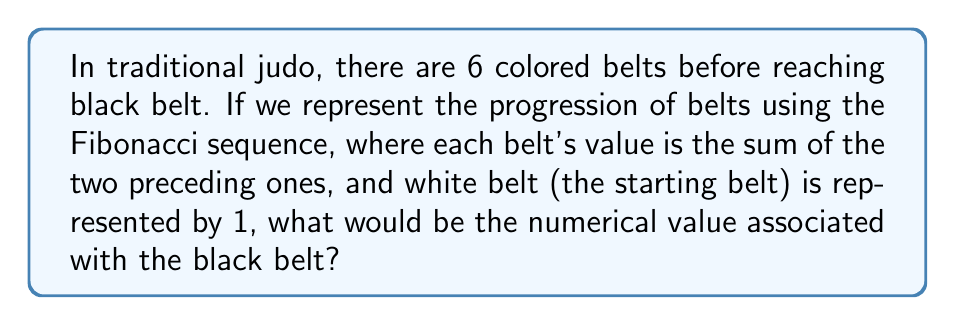Show me your answer to this math problem. Let's approach this step-by-step:

1) The Fibonacci sequence starts with 1, 1, and each subsequent number is the sum of the two preceding ones.

2) The belt progression in judo typically follows this order: White, Yellow, Orange, Green, Blue, Brown, Black.

3) Let's assign the Fibonacci numbers to each belt:

   White: 1
   Yellow: 1
   Orange: $1 + 1 = 2$
   Green: $1 + 2 = 3$
   Blue: $2 + 3 = 5$
   Brown: $3 + 5 = 8$
   Black: $5 + 8 = 13$

4) We can represent this mathematically as:

   $$F_n = F_{n-1} + F_{n-2}$$

   Where $F_n$ is the nth term in the Fibonacci sequence.

5) In this case, the black belt is the 7th term in our sequence (as it's the 7th belt), so we're looking for $F_7$.

6) The sequence for the belts is thus:

   $$1, 1, 2, 3, 5, 8, 13$$

Therefore, the black belt is represented by the number 13 in this Fibonacci sequence.
Answer: 13 